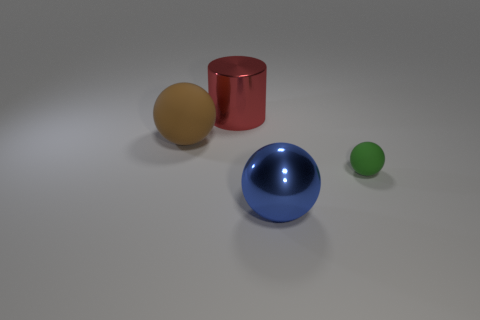The large rubber object is what shape?
Keep it short and to the point. Sphere. What number of things are objects to the left of the big cylinder or brown things?
Make the answer very short. 1. There is a sphere that is the same material as the red thing; what size is it?
Offer a terse response. Large. Are there more big metal things that are behind the large red thing than brown matte things?
Ensure brevity in your answer.  No. There is a big blue shiny object; does it have the same shape as the big object that is left of the cylinder?
Offer a very short reply. Yes. How many small things are either balls or purple metal balls?
Ensure brevity in your answer.  1. There is a large sphere that is on the left side of the big metallic thing in front of the brown rubber thing; what color is it?
Provide a short and direct response. Brown. Are the large blue thing and the sphere behind the small green rubber sphere made of the same material?
Offer a very short reply. No. There is a object to the left of the large red shiny thing; what is its material?
Your response must be concise. Rubber. Is the number of blue spheres behind the small green rubber thing the same as the number of big shiny balls?
Keep it short and to the point. No. 